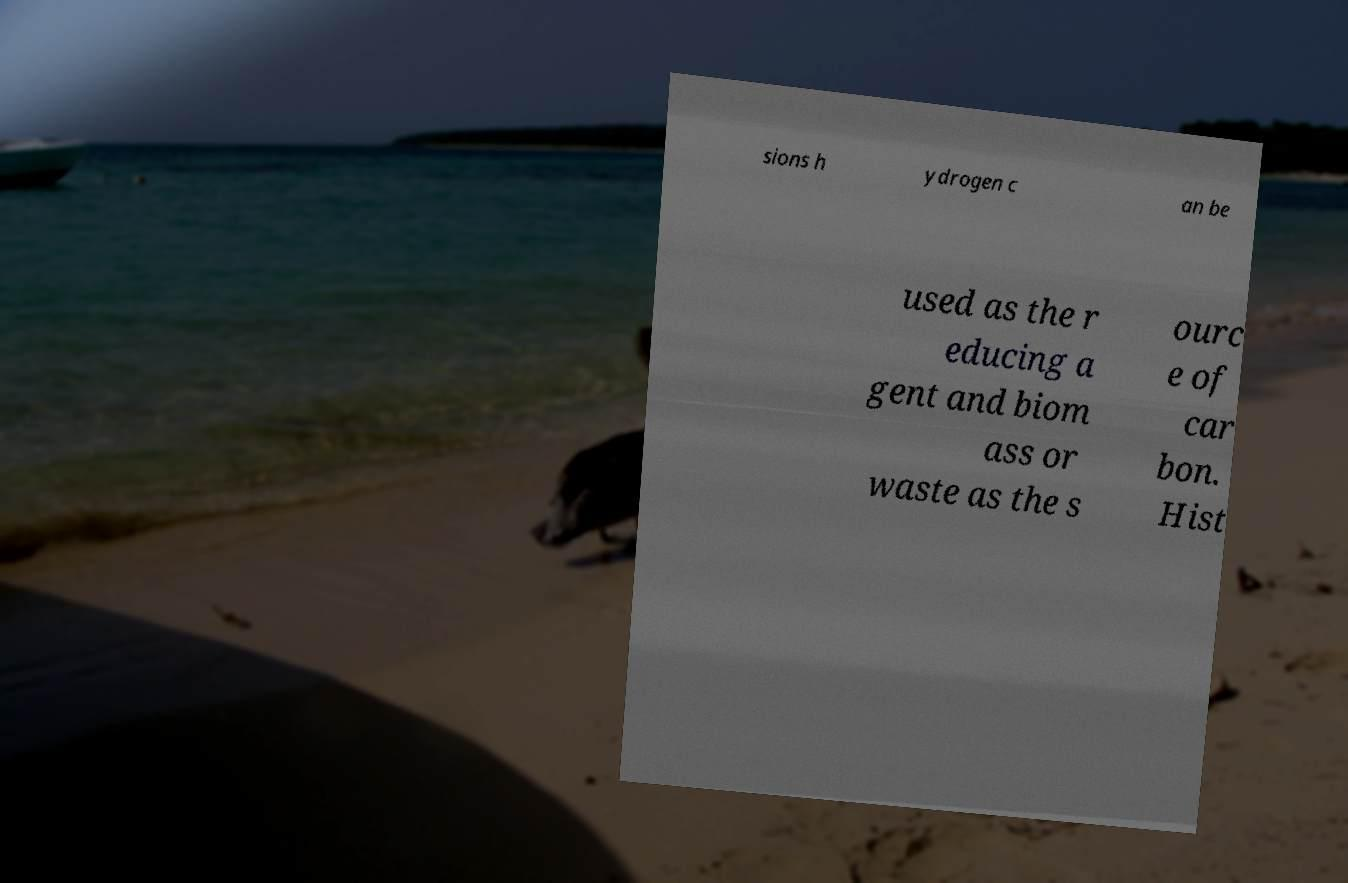I need the written content from this picture converted into text. Can you do that? sions h ydrogen c an be used as the r educing a gent and biom ass or waste as the s ourc e of car bon. Hist 